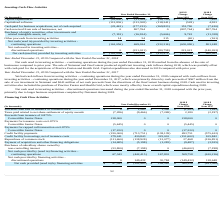According to Allscripts Healthcare Solutions's financial document, What led to Net cash used in investing activities – continuing operations during the year ended December 31, 2019? the absence of the sale of businesses compared to prior year. The document states: "ng the year ended December 31, 2019 resulted from the absence of the sale of businesses compared to prior year. The sale of Netsmart and OneContent pr..." Also, What was the impact of the sale of Netsmart and OneContent? produced significant investing cash inflows during 2018, which was partially offset with cash paid for the acquisitions of Practice Fusion and Health Grid.. The document states: "to prior year. The sale of Netsmart and OneContent produced significant investing cash inflows during 2018, which was partially offset with cash paid ..." Also, How much was the net cash proceeds from the divestiture of the OneContent business during 2018? According to the financial document, $241 million. The relevant text states: "on from the sale of our investment in Netsmart and $241 million of net cash proceeds from the divestiture of the OneContent business during 2018. Cash used in inves..." Also, can you calculate: What is the average Capital expenditures, for the year 2019 to 2018? To answer this question, I need to perform calculations using the financial data. The calculation is: -(16,600+31,309) / 2, which equals -23954.5 (in thousands). This is based on the information: "Capital expenditures $ (16,600) $ (31,309) $ (38,759) $ 14,709 $ 7,450 Capital expenditures $ (16,600) $ (31,309) $ (38,759) $ 14,709 $ 7,450..." The key data points involved are: 16,600, 31,309. Also, can you calculate: What is the average Capitalized software, for the year 2019 to 2018? To answer this question, I need to perform calculations using the financial data. The calculation is: -(113,836+113,308) / 2, which equals -113572 (in thousands). This is based on the information: "Capitalized software (113,836) (113,308) (118,241) (528) 4,933 Capitalized software (113,836) (113,308) (118,241) (528) 4,933..." The key data points involved are: 113,308, 113,836. Also, can you calculate: What is the average Cash paid for business acquisitions, net of cash acquired, for the year 2019 to 2018? To answer this question, I need to perform calculations using the financial data. The calculation is: -(23,443+177,233) / 2, which equals -100338 (in thousands). This is based on the information: "ness acquisitions, net of cash acquired (23,443) (177,233) (169,823) 153,790 (7,410) for business acquisitions, net of cash acquired (23,443) (177,233) (169,823) 153,790 (7,410)..." The key data points involved are: 177,233, 23,443. 